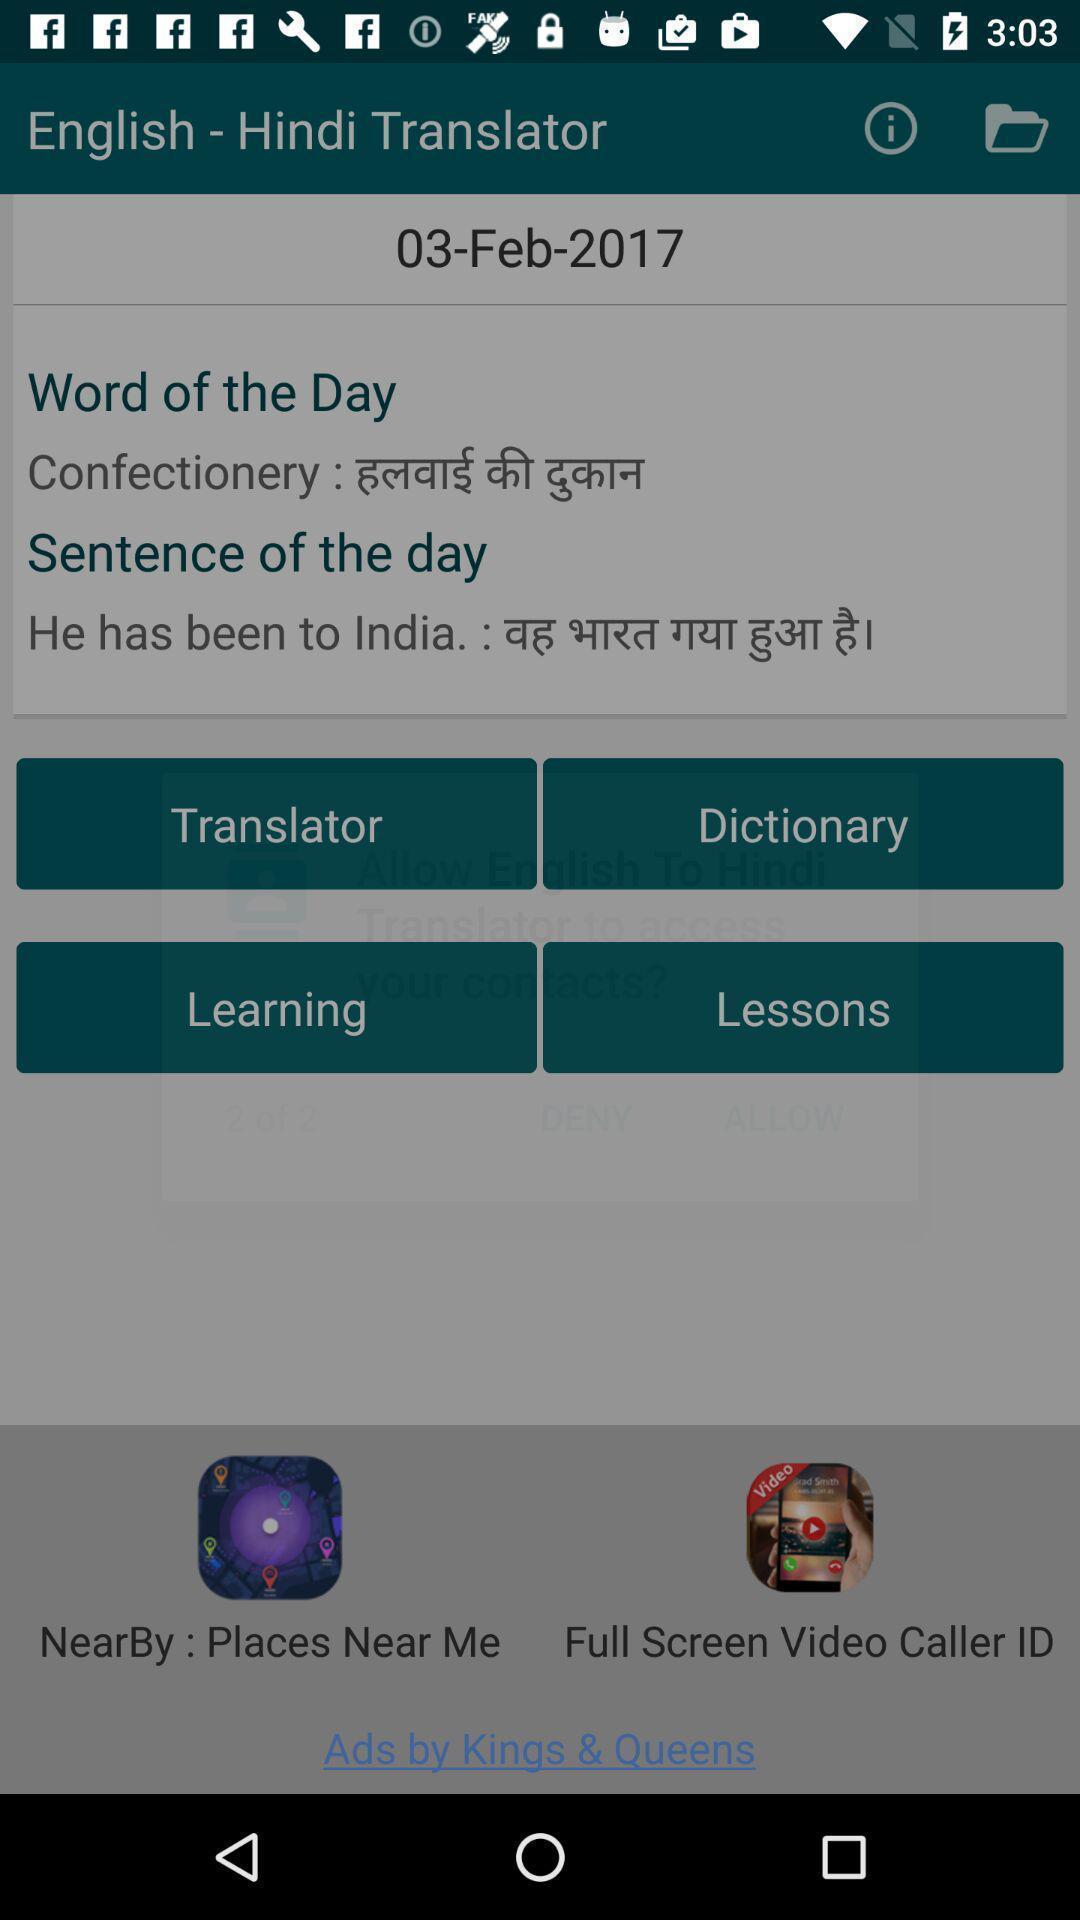What is the overall content of this screenshot? Page displays options in translator app. 